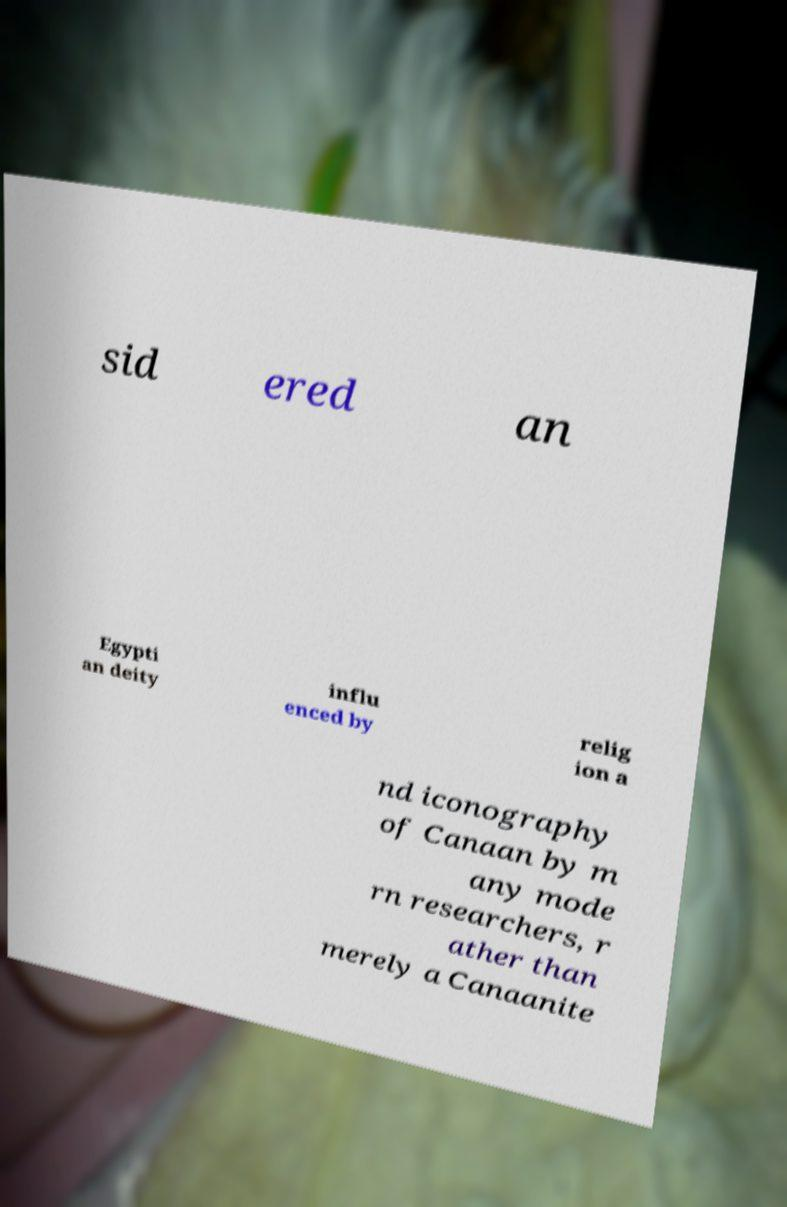Can you accurately transcribe the text from the provided image for me? sid ered an Egypti an deity influ enced by relig ion a nd iconography of Canaan by m any mode rn researchers, r ather than merely a Canaanite 